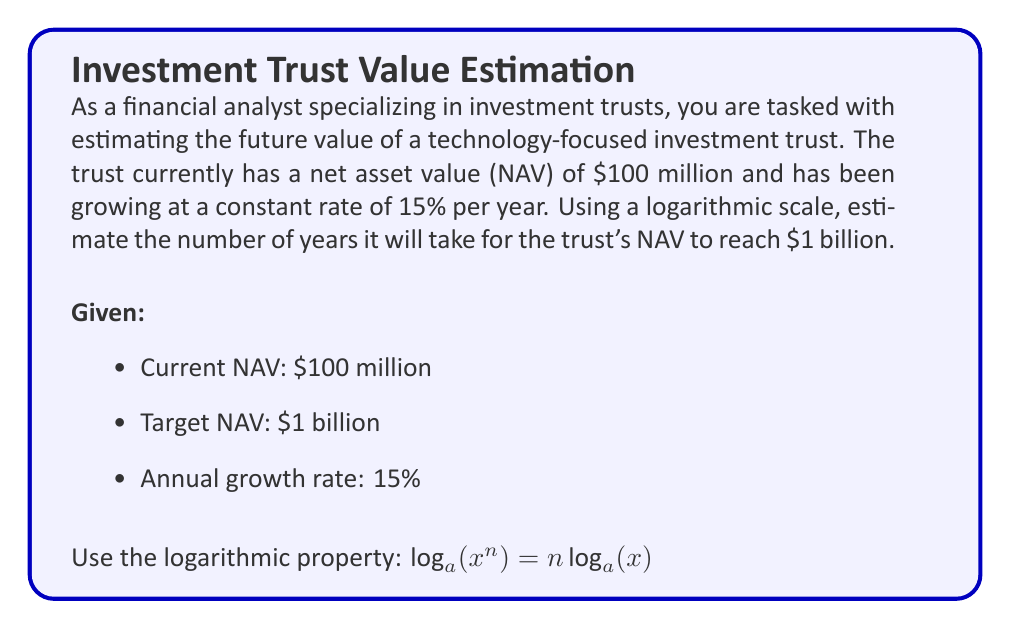Help me with this question. To solve this problem, we'll use the compound interest formula and apply logarithms to isolate the time variable. Let's approach this step-by-step:

1) The compound interest formula is:
   $$A = P(1 + r)^t$$
   Where:
   $A$ = final amount
   $P$ = principal (initial investment)
   $r$ = annual interest rate (as a decimal)
   $t$ = time in years

2) Plugging in our values:
   $$1,000,000,000 = 100,000,000(1 + 0.15)^t$$

3) Divide both sides by 100,000,000:
   $$10 = (1.15)^t$$

4) Now, let's apply logarithms to both sides. We can use any base, but let's use base 10 for simplicity:
   $$\log_{10}(10) = \log_{10}((1.15)^t)$$

5) Using the logarithmic property $\log_a(x^n) = n\log_a(x)$:
   $$1 = t \cdot \log_{10}(1.15)$$

6) Solve for $t$:
   $$t = \frac{1}{\log_{10}(1.15)}$$

7) Calculate:
   $$t = \frac{1}{\log_{10}(1.15)} \approx 16.58$$

Therefore, it will take approximately 16.58 years for the investment trust's NAV to grow from $100 million to $1 billion at a 15% annual growth rate.
Answer: Approximately 16.58 years 